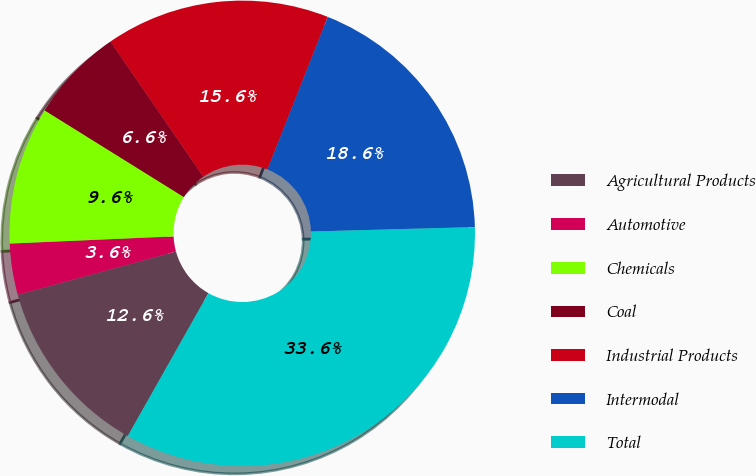Convert chart to OTSL. <chart><loc_0><loc_0><loc_500><loc_500><pie_chart><fcel>Agricultural Products<fcel>Automotive<fcel>Chemicals<fcel>Coal<fcel>Industrial Products<fcel>Intermodal<fcel>Total<nl><fcel>12.57%<fcel>3.55%<fcel>9.56%<fcel>6.56%<fcel>15.57%<fcel>18.58%<fcel>33.61%<nl></chart> 